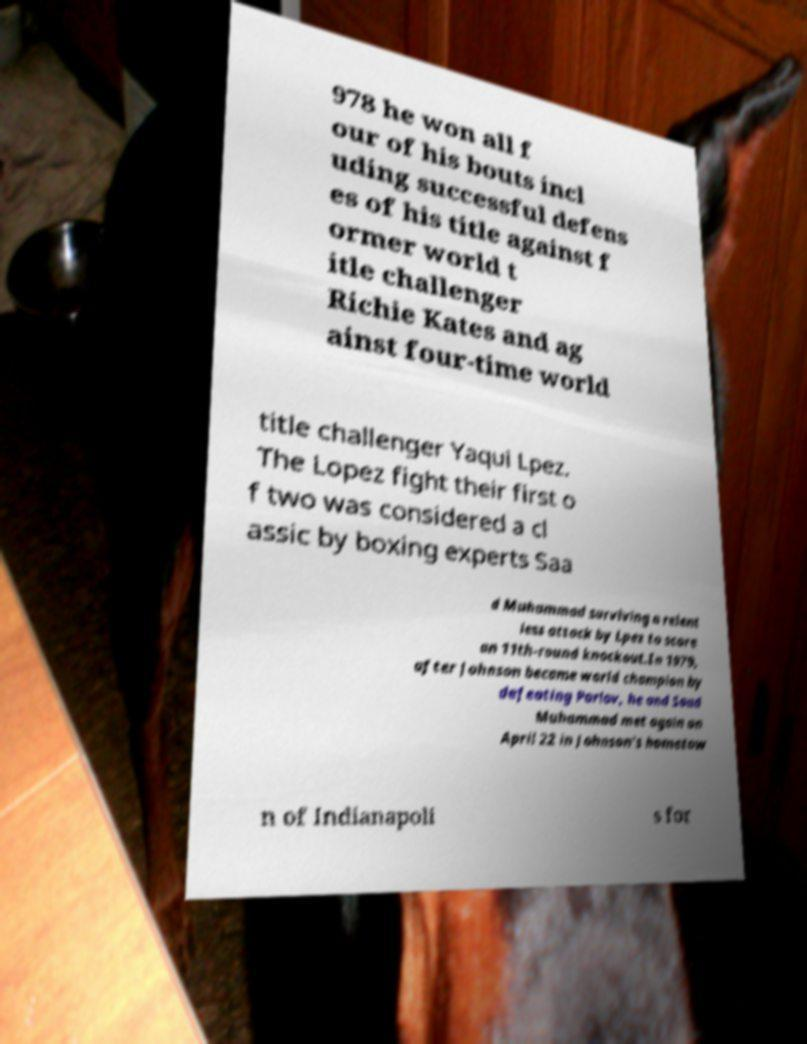Could you assist in decoding the text presented in this image and type it out clearly? 978 he won all f our of his bouts incl uding successful defens es of his title against f ormer world t itle challenger Richie Kates and ag ainst four-time world title challenger Yaqui Lpez. The Lopez fight their first o f two was considered a cl assic by boxing experts Saa d Muhammad surviving a relent less attack by Lpez to score an 11th-round knockout.In 1979, after Johnson became world champion by defeating Parlov, he and Saad Muhammad met again on April 22 in Johnson's hometow n of Indianapoli s for 